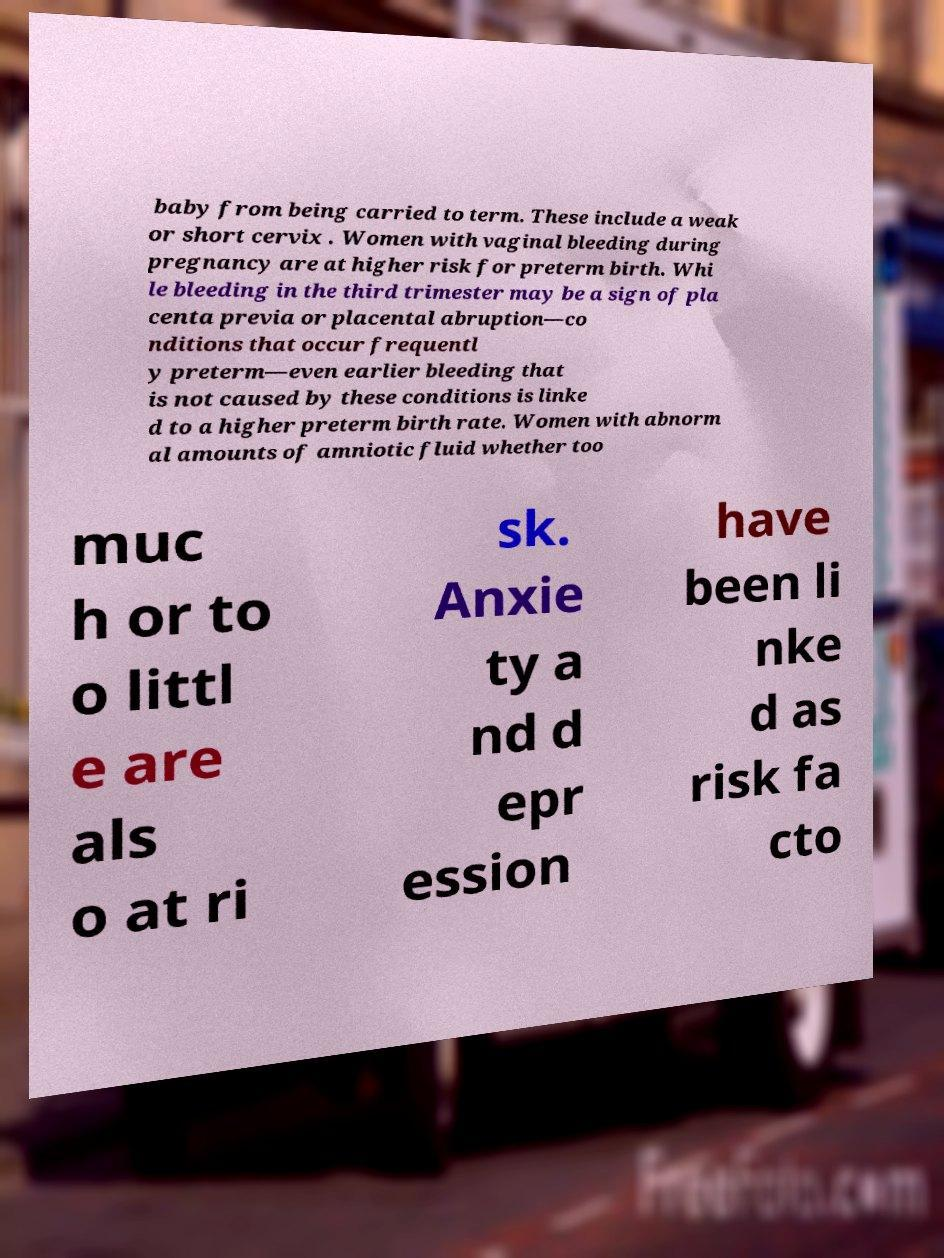Please identify and transcribe the text found in this image. baby from being carried to term. These include a weak or short cervix . Women with vaginal bleeding during pregnancy are at higher risk for preterm birth. Whi le bleeding in the third trimester may be a sign of pla centa previa or placental abruption—co nditions that occur frequentl y preterm—even earlier bleeding that is not caused by these conditions is linke d to a higher preterm birth rate. Women with abnorm al amounts of amniotic fluid whether too muc h or to o littl e are als o at ri sk. Anxie ty a nd d epr ession have been li nke d as risk fa cto 